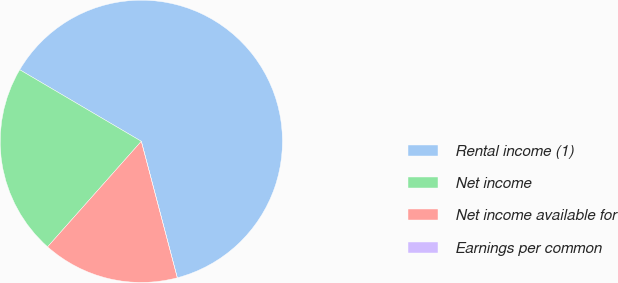Convert chart. <chart><loc_0><loc_0><loc_500><loc_500><pie_chart><fcel>Rental income (1)<fcel>Net income<fcel>Net income available for<fcel>Earnings per common<nl><fcel>62.43%<fcel>21.91%<fcel>15.66%<fcel>0.0%<nl></chart> 